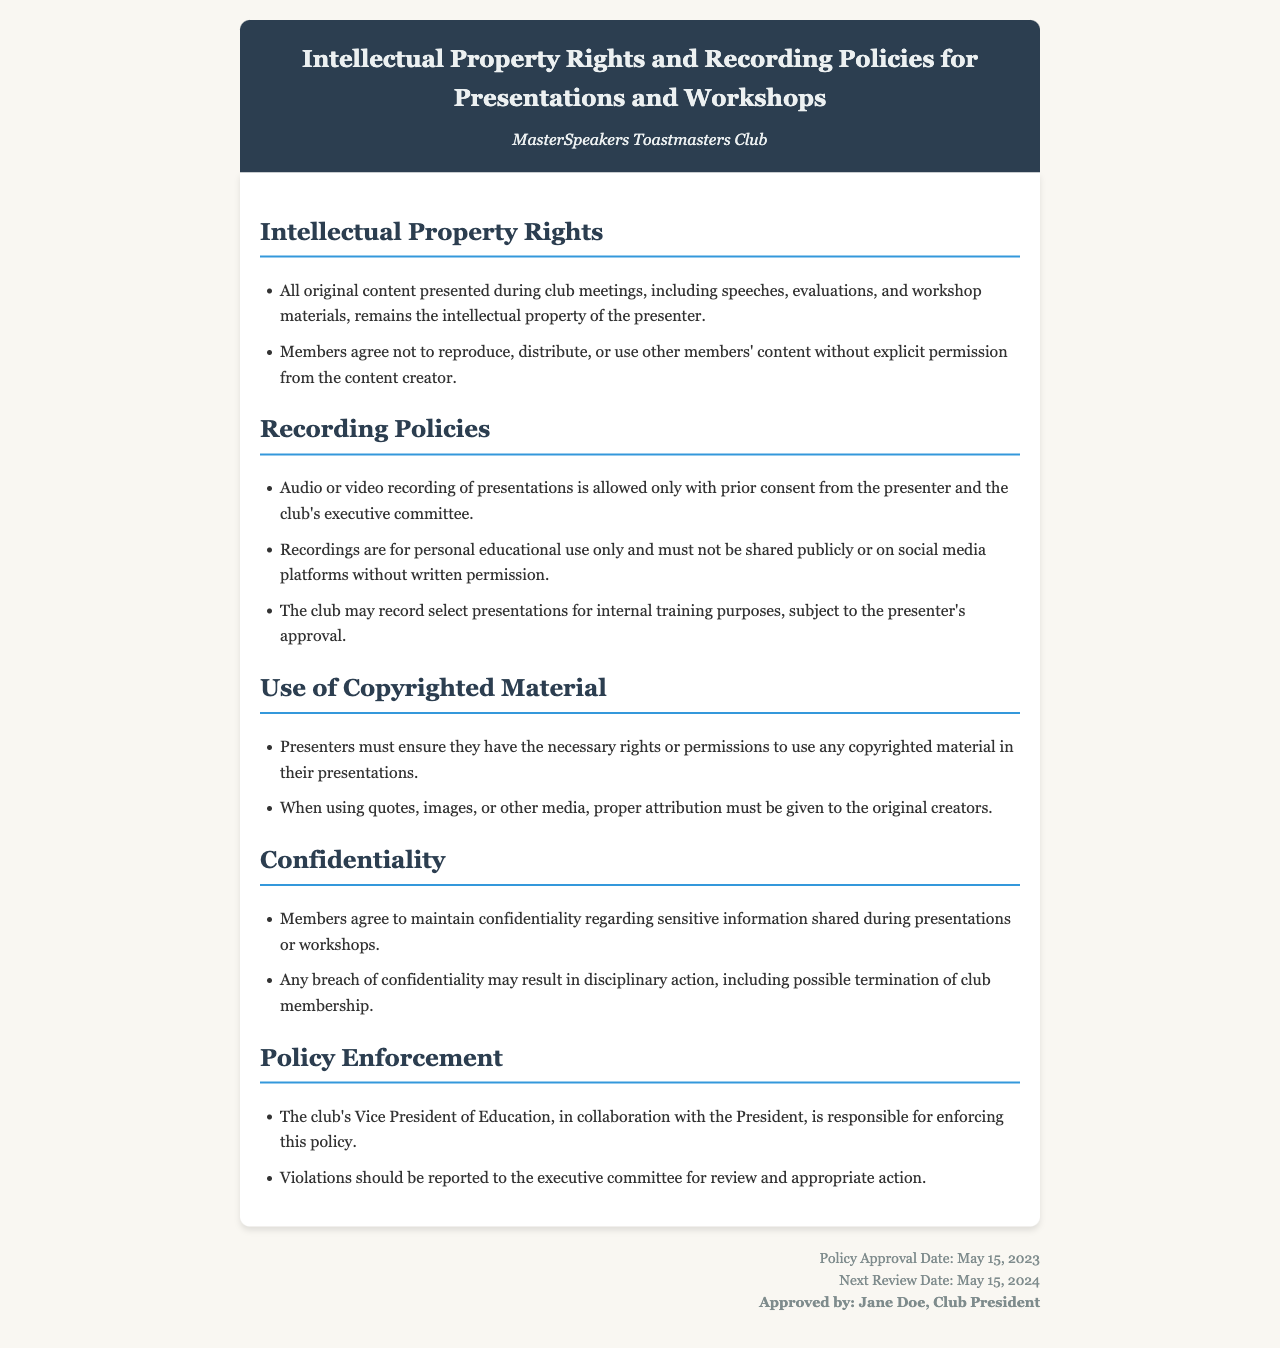What is the title of the policy document? The title is given in the header section of the document.
Answer: Intellectual Property Rights and Recording Policies for Presentations and Workshops Who approved the policy? The document mentions the approval in the footer section, specifying the person who approved it.
Answer: Jane Doe, Club President What is the policy approval date? The approval date is stated in the footer section of the document.
Answer: May 15, 2023 Who is responsible for enforcing this policy? The document outlines the enforcement responsibilities in the Policy Enforcement section.
Answer: Vice President of Education and President What must members obtain for recording? The Recording Policies section specifies what is needed before recording presentations.
Answer: Prior consent What is the next review date for this policy? The next review date is mentioned in the footer section of the document.
Answer: May 15, 2024 What should presenters do with copyrighted material? The Use of Copyrighted Material section describes the presenters' obligations regarding this.
Answer: Ensure necessary rights or permissions What happens in case of a breach of confidentiality? The document states potential consequences for breaching confidentiality.
Answer: Disciplinary action What are recordings primarily for? The Recording Policies section specifies the intended use for recordings.
Answer: Personal educational use only 